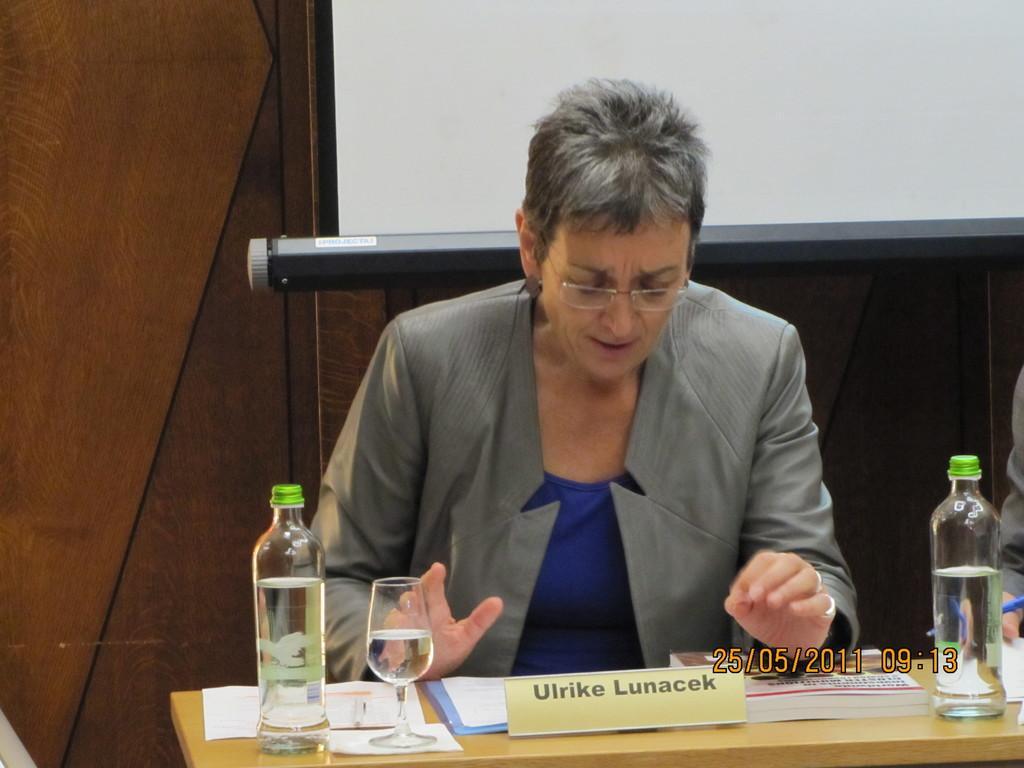Describe this image in one or two sentences. A lady is sitting wearing a specs. And there is a table. On the table there is a name plate glass bottle and some papers. In the background there is a wooden wall. 